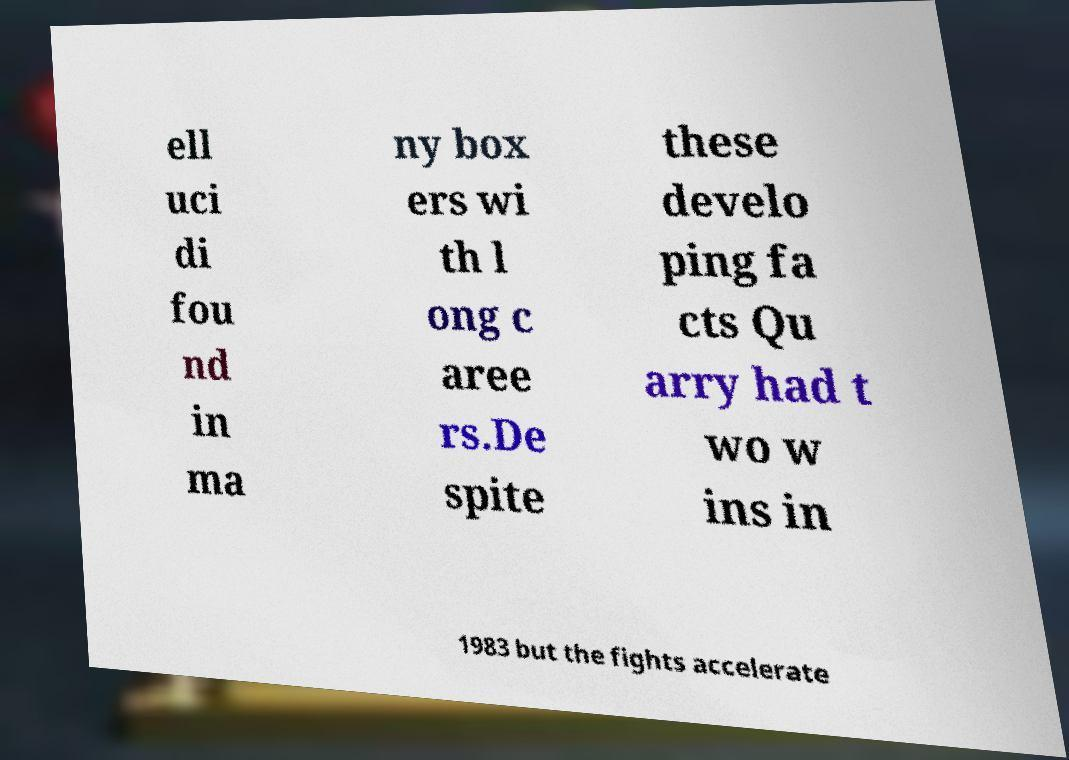I need the written content from this picture converted into text. Can you do that? ell uci di fou nd in ma ny box ers wi th l ong c aree rs.De spite these develo ping fa cts Qu arry had t wo w ins in 1983 but the fights accelerate 